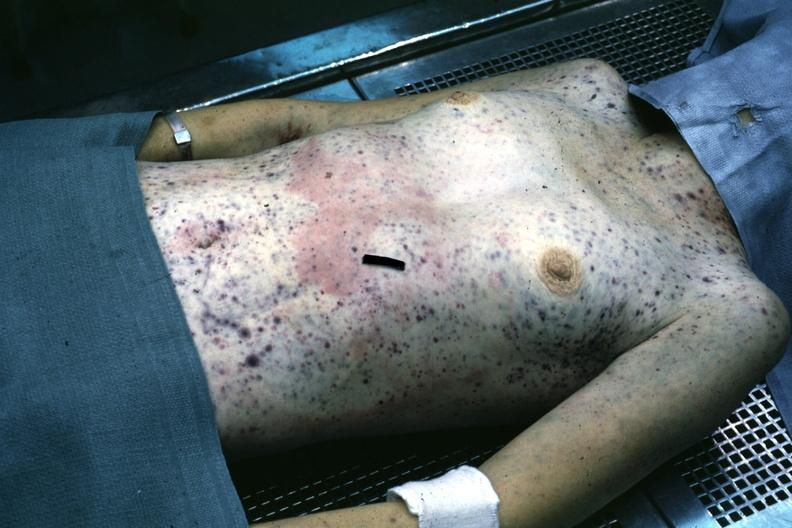what does this image show?
Answer the question using a single word or phrase. But not good color many petechial and purpuric hemorrhages case of stcell leukemia 